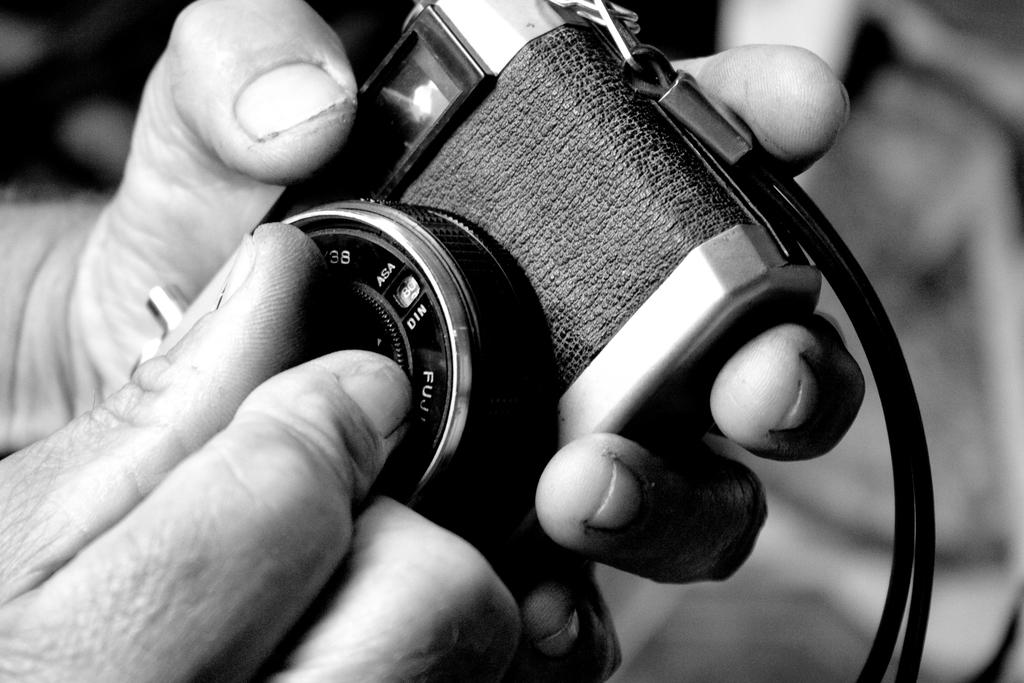What is the person in the image doing? The person is holding a camera and adjusting the lens of the camera. What can be inferred about the person's activity from the image? The person appears to be engaged in photography, as they are adjusting the lens of the camera. What is the color of the camera lens? The lens is black in color. What is visible behind the person in the image? The backdrop of the image is clear. What type of mint is growing in the background of the image? There is no mint visible in the image; the backdrop is clear. Can you tell me how many shops are present in the image? There are no shops present in the image; it features a person adjusting the lens of a camera. 